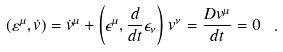<formula> <loc_0><loc_0><loc_500><loc_500>( \varepsilon ^ { \mu } , \dot { v } ) = \dot { v } ^ { \mu } + \left ( \epsilon ^ { \mu } , \frac { d } { d t } \epsilon _ { \nu } \right ) \, v ^ { \nu } = \frac { D v ^ { \mu } } { d t } = 0 \ .</formula> 